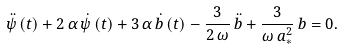<formula> <loc_0><loc_0><loc_500><loc_500>\ddot { \psi } \left ( t \right ) + 2 \, \alpha \, \dot { \psi } \left ( t \right ) + 3 \, \alpha \, \dot { b } \left ( t \right ) - \frac { 3 } { 2 \, \omega } \, \ddot { b } + \frac { 3 } { \omega \, a _ { \ast } ^ { 2 } } \, b = 0 .</formula> 